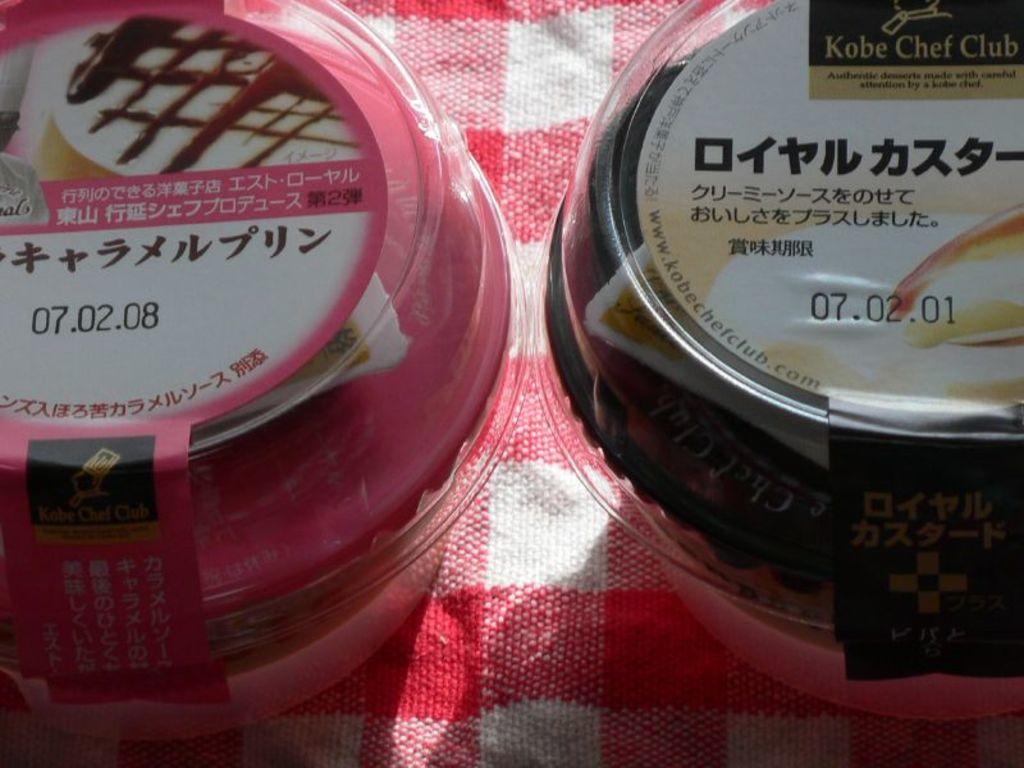What is the brand name shown on the black container?
Offer a very short reply. Kobe chef club. 